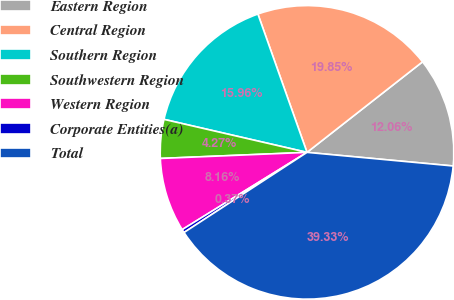Convert chart. <chart><loc_0><loc_0><loc_500><loc_500><pie_chart><fcel>Eastern Region<fcel>Central Region<fcel>Southern Region<fcel>Southwestern Region<fcel>Western Region<fcel>Corporate Entities(a)<fcel>Total<nl><fcel>12.06%<fcel>19.85%<fcel>15.96%<fcel>4.27%<fcel>8.16%<fcel>0.37%<fcel>39.33%<nl></chart> 